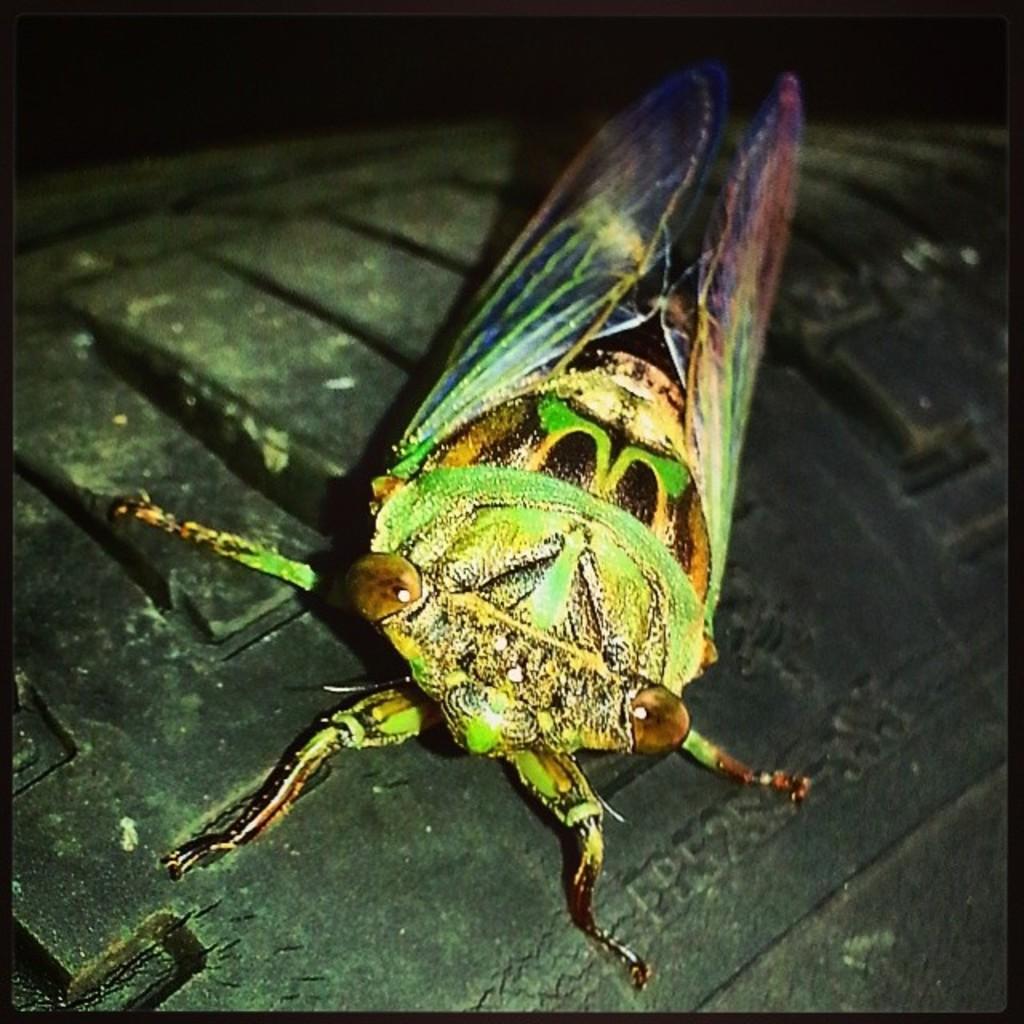How would you summarize this image in a sentence or two? In the center of the image we can see an insect is present on a tire. 